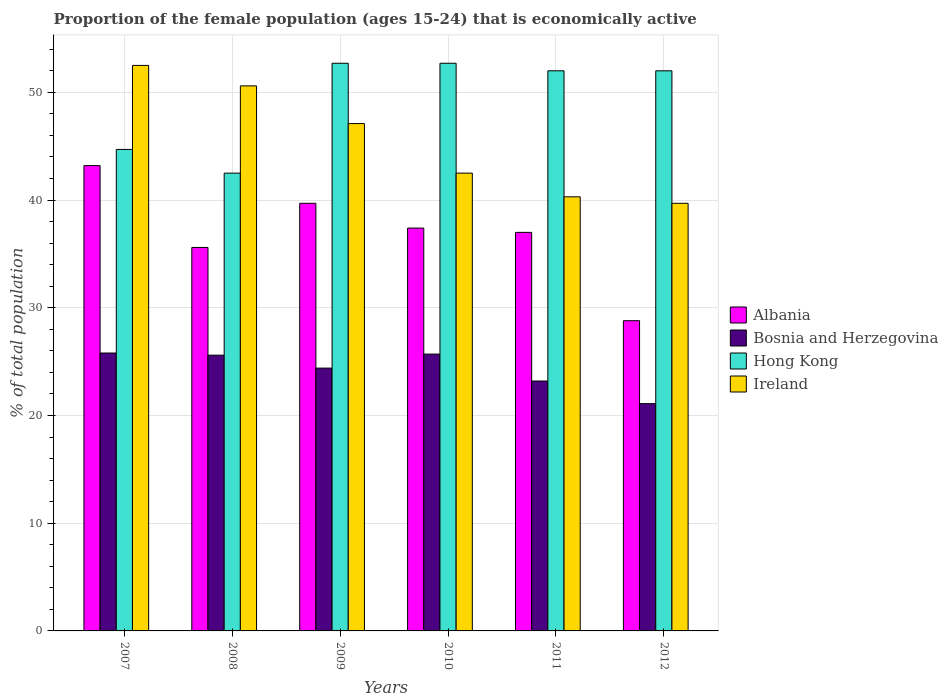How many different coloured bars are there?
Keep it short and to the point. 4. How many groups of bars are there?
Ensure brevity in your answer.  6. Are the number of bars per tick equal to the number of legend labels?
Your answer should be compact. Yes. What is the proportion of the female population that is economically active in Hong Kong in 2010?
Your answer should be very brief. 52.7. Across all years, what is the maximum proportion of the female population that is economically active in Ireland?
Keep it short and to the point. 52.5. Across all years, what is the minimum proportion of the female population that is economically active in Bosnia and Herzegovina?
Offer a terse response. 21.1. In which year was the proportion of the female population that is economically active in Hong Kong maximum?
Offer a terse response. 2009. In which year was the proportion of the female population that is economically active in Bosnia and Herzegovina minimum?
Make the answer very short. 2012. What is the total proportion of the female population that is economically active in Albania in the graph?
Your answer should be very brief. 221.7. What is the difference between the proportion of the female population that is economically active in Bosnia and Herzegovina in 2009 and that in 2010?
Make the answer very short. -1.3. What is the difference between the proportion of the female population that is economically active in Albania in 2008 and the proportion of the female population that is economically active in Bosnia and Herzegovina in 2012?
Offer a very short reply. 14.5. What is the average proportion of the female population that is economically active in Bosnia and Herzegovina per year?
Keep it short and to the point. 24.3. In the year 2012, what is the difference between the proportion of the female population that is economically active in Albania and proportion of the female population that is economically active in Hong Kong?
Your response must be concise. -23.2. In how many years, is the proportion of the female population that is economically active in Ireland greater than 52 %?
Offer a terse response. 1. What is the ratio of the proportion of the female population that is economically active in Albania in 2009 to that in 2011?
Your response must be concise. 1.07. Is the proportion of the female population that is economically active in Hong Kong in 2007 less than that in 2011?
Your answer should be very brief. Yes. What is the difference between the highest and the second highest proportion of the female population that is economically active in Bosnia and Herzegovina?
Offer a very short reply. 0.1. What is the difference between the highest and the lowest proportion of the female population that is economically active in Hong Kong?
Keep it short and to the point. 10.2. Is it the case that in every year, the sum of the proportion of the female population that is economically active in Ireland and proportion of the female population that is economically active in Bosnia and Herzegovina is greater than the sum of proportion of the female population that is economically active in Albania and proportion of the female population that is economically active in Hong Kong?
Offer a very short reply. No. What does the 4th bar from the left in 2011 represents?
Provide a short and direct response. Ireland. What does the 3rd bar from the right in 2007 represents?
Keep it short and to the point. Bosnia and Herzegovina. Are all the bars in the graph horizontal?
Your answer should be compact. No. How many years are there in the graph?
Provide a succinct answer. 6. Does the graph contain grids?
Make the answer very short. Yes. What is the title of the graph?
Provide a succinct answer. Proportion of the female population (ages 15-24) that is economically active. What is the label or title of the Y-axis?
Offer a very short reply. % of total population. What is the % of total population in Albania in 2007?
Keep it short and to the point. 43.2. What is the % of total population in Bosnia and Herzegovina in 2007?
Offer a very short reply. 25.8. What is the % of total population of Hong Kong in 2007?
Give a very brief answer. 44.7. What is the % of total population in Ireland in 2007?
Your answer should be very brief. 52.5. What is the % of total population of Albania in 2008?
Provide a short and direct response. 35.6. What is the % of total population in Bosnia and Herzegovina in 2008?
Keep it short and to the point. 25.6. What is the % of total population in Hong Kong in 2008?
Offer a very short reply. 42.5. What is the % of total population of Ireland in 2008?
Keep it short and to the point. 50.6. What is the % of total population in Albania in 2009?
Provide a short and direct response. 39.7. What is the % of total population of Bosnia and Herzegovina in 2009?
Keep it short and to the point. 24.4. What is the % of total population of Hong Kong in 2009?
Offer a very short reply. 52.7. What is the % of total population in Ireland in 2009?
Provide a short and direct response. 47.1. What is the % of total population of Albania in 2010?
Give a very brief answer. 37.4. What is the % of total population of Bosnia and Herzegovina in 2010?
Make the answer very short. 25.7. What is the % of total population of Hong Kong in 2010?
Provide a succinct answer. 52.7. What is the % of total population of Ireland in 2010?
Your response must be concise. 42.5. What is the % of total population in Albania in 2011?
Your answer should be compact. 37. What is the % of total population of Bosnia and Herzegovina in 2011?
Give a very brief answer. 23.2. What is the % of total population of Ireland in 2011?
Your answer should be compact. 40.3. What is the % of total population in Albania in 2012?
Give a very brief answer. 28.8. What is the % of total population in Bosnia and Herzegovina in 2012?
Keep it short and to the point. 21.1. What is the % of total population of Hong Kong in 2012?
Your answer should be compact. 52. What is the % of total population in Ireland in 2012?
Ensure brevity in your answer.  39.7. Across all years, what is the maximum % of total population in Albania?
Ensure brevity in your answer.  43.2. Across all years, what is the maximum % of total population of Bosnia and Herzegovina?
Your response must be concise. 25.8. Across all years, what is the maximum % of total population of Hong Kong?
Provide a succinct answer. 52.7. Across all years, what is the maximum % of total population of Ireland?
Provide a succinct answer. 52.5. Across all years, what is the minimum % of total population of Albania?
Your answer should be very brief. 28.8. Across all years, what is the minimum % of total population in Bosnia and Herzegovina?
Give a very brief answer. 21.1. Across all years, what is the minimum % of total population of Hong Kong?
Your answer should be very brief. 42.5. Across all years, what is the minimum % of total population in Ireland?
Make the answer very short. 39.7. What is the total % of total population in Albania in the graph?
Keep it short and to the point. 221.7. What is the total % of total population in Bosnia and Herzegovina in the graph?
Your answer should be compact. 145.8. What is the total % of total population in Hong Kong in the graph?
Make the answer very short. 296.6. What is the total % of total population of Ireland in the graph?
Provide a short and direct response. 272.7. What is the difference between the % of total population of Hong Kong in 2007 and that in 2008?
Keep it short and to the point. 2.2. What is the difference between the % of total population of Ireland in 2007 and that in 2008?
Your answer should be compact. 1.9. What is the difference between the % of total population in Albania in 2007 and that in 2009?
Provide a short and direct response. 3.5. What is the difference between the % of total population of Ireland in 2007 and that in 2009?
Keep it short and to the point. 5.4. What is the difference between the % of total population of Albania in 2007 and that in 2010?
Your response must be concise. 5.8. What is the difference between the % of total population of Hong Kong in 2007 and that in 2010?
Provide a short and direct response. -8. What is the difference between the % of total population in Ireland in 2007 and that in 2010?
Provide a short and direct response. 10. What is the difference between the % of total population of Bosnia and Herzegovina in 2007 and that in 2011?
Offer a very short reply. 2.6. What is the difference between the % of total population in Ireland in 2007 and that in 2011?
Provide a short and direct response. 12.2. What is the difference between the % of total population in Albania in 2008 and that in 2009?
Make the answer very short. -4.1. What is the difference between the % of total population in Hong Kong in 2008 and that in 2009?
Your answer should be compact. -10.2. What is the difference between the % of total population of Ireland in 2008 and that in 2010?
Offer a very short reply. 8.1. What is the difference between the % of total population in Ireland in 2008 and that in 2011?
Provide a short and direct response. 10.3. What is the difference between the % of total population in Bosnia and Herzegovina in 2008 and that in 2012?
Offer a very short reply. 4.5. What is the difference between the % of total population in Hong Kong in 2008 and that in 2012?
Make the answer very short. -9.5. What is the difference between the % of total population of Ireland in 2008 and that in 2012?
Your answer should be compact. 10.9. What is the difference between the % of total population of Albania in 2009 and that in 2011?
Make the answer very short. 2.7. What is the difference between the % of total population in Bosnia and Herzegovina in 2009 and that in 2011?
Keep it short and to the point. 1.2. What is the difference between the % of total population in Hong Kong in 2009 and that in 2011?
Make the answer very short. 0.7. What is the difference between the % of total population of Ireland in 2009 and that in 2011?
Keep it short and to the point. 6.8. What is the difference between the % of total population in Hong Kong in 2009 and that in 2012?
Your answer should be very brief. 0.7. What is the difference between the % of total population in Bosnia and Herzegovina in 2010 and that in 2011?
Offer a very short reply. 2.5. What is the difference between the % of total population of Hong Kong in 2010 and that in 2012?
Provide a short and direct response. 0.7. What is the difference between the % of total population of Ireland in 2010 and that in 2012?
Provide a succinct answer. 2.8. What is the difference between the % of total population in Albania in 2011 and that in 2012?
Ensure brevity in your answer.  8.2. What is the difference between the % of total population in Hong Kong in 2011 and that in 2012?
Ensure brevity in your answer.  0. What is the difference between the % of total population of Ireland in 2011 and that in 2012?
Provide a succinct answer. 0.6. What is the difference between the % of total population of Albania in 2007 and the % of total population of Ireland in 2008?
Ensure brevity in your answer.  -7.4. What is the difference between the % of total population of Bosnia and Herzegovina in 2007 and the % of total population of Hong Kong in 2008?
Make the answer very short. -16.7. What is the difference between the % of total population of Bosnia and Herzegovina in 2007 and the % of total population of Ireland in 2008?
Your response must be concise. -24.8. What is the difference between the % of total population in Hong Kong in 2007 and the % of total population in Ireland in 2008?
Your answer should be compact. -5.9. What is the difference between the % of total population in Albania in 2007 and the % of total population in Bosnia and Herzegovina in 2009?
Ensure brevity in your answer.  18.8. What is the difference between the % of total population of Albania in 2007 and the % of total population of Hong Kong in 2009?
Your response must be concise. -9.5. What is the difference between the % of total population of Bosnia and Herzegovina in 2007 and the % of total population of Hong Kong in 2009?
Your response must be concise. -26.9. What is the difference between the % of total population of Bosnia and Herzegovina in 2007 and the % of total population of Ireland in 2009?
Offer a terse response. -21.3. What is the difference between the % of total population of Hong Kong in 2007 and the % of total population of Ireland in 2009?
Provide a succinct answer. -2.4. What is the difference between the % of total population in Albania in 2007 and the % of total population in Ireland in 2010?
Your answer should be very brief. 0.7. What is the difference between the % of total population in Bosnia and Herzegovina in 2007 and the % of total population in Hong Kong in 2010?
Ensure brevity in your answer.  -26.9. What is the difference between the % of total population in Bosnia and Herzegovina in 2007 and the % of total population in Ireland in 2010?
Your answer should be very brief. -16.7. What is the difference between the % of total population in Bosnia and Herzegovina in 2007 and the % of total population in Hong Kong in 2011?
Your response must be concise. -26.2. What is the difference between the % of total population in Bosnia and Herzegovina in 2007 and the % of total population in Ireland in 2011?
Make the answer very short. -14.5. What is the difference between the % of total population in Albania in 2007 and the % of total population in Bosnia and Herzegovina in 2012?
Offer a terse response. 22.1. What is the difference between the % of total population in Albania in 2007 and the % of total population in Hong Kong in 2012?
Your answer should be compact. -8.8. What is the difference between the % of total population of Albania in 2007 and the % of total population of Ireland in 2012?
Make the answer very short. 3.5. What is the difference between the % of total population of Bosnia and Herzegovina in 2007 and the % of total population of Hong Kong in 2012?
Your response must be concise. -26.2. What is the difference between the % of total population of Albania in 2008 and the % of total population of Bosnia and Herzegovina in 2009?
Provide a succinct answer. 11.2. What is the difference between the % of total population of Albania in 2008 and the % of total population of Hong Kong in 2009?
Your answer should be very brief. -17.1. What is the difference between the % of total population of Albania in 2008 and the % of total population of Ireland in 2009?
Offer a very short reply. -11.5. What is the difference between the % of total population in Bosnia and Herzegovina in 2008 and the % of total population in Hong Kong in 2009?
Provide a succinct answer. -27.1. What is the difference between the % of total population in Bosnia and Herzegovina in 2008 and the % of total population in Ireland in 2009?
Your response must be concise. -21.5. What is the difference between the % of total population in Hong Kong in 2008 and the % of total population in Ireland in 2009?
Offer a terse response. -4.6. What is the difference between the % of total population of Albania in 2008 and the % of total population of Bosnia and Herzegovina in 2010?
Provide a short and direct response. 9.9. What is the difference between the % of total population of Albania in 2008 and the % of total population of Hong Kong in 2010?
Offer a terse response. -17.1. What is the difference between the % of total population of Bosnia and Herzegovina in 2008 and the % of total population of Hong Kong in 2010?
Make the answer very short. -27.1. What is the difference between the % of total population of Bosnia and Herzegovina in 2008 and the % of total population of Ireland in 2010?
Your response must be concise. -16.9. What is the difference between the % of total population in Hong Kong in 2008 and the % of total population in Ireland in 2010?
Make the answer very short. 0. What is the difference between the % of total population in Albania in 2008 and the % of total population in Hong Kong in 2011?
Provide a succinct answer. -16.4. What is the difference between the % of total population in Bosnia and Herzegovina in 2008 and the % of total population in Hong Kong in 2011?
Give a very brief answer. -26.4. What is the difference between the % of total population in Bosnia and Herzegovina in 2008 and the % of total population in Ireland in 2011?
Keep it short and to the point. -14.7. What is the difference between the % of total population in Hong Kong in 2008 and the % of total population in Ireland in 2011?
Provide a short and direct response. 2.2. What is the difference between the % of total population in Albania in 2008 and the % of total population in Bosnia and Herzegovina in 2012?
Your answer should be compact. 14.5. What is the difference between the % of total population of Albania in 2008 and the % of total population of Hong Kong in 2012?
Keep it short and to the point. -16.4. What is the difference between the % of total population in Albania in 2008 and the % of total population in Ireland in 2012?
Ensure brevity in your answer.  -4.1. What is the difference between the % of total population of Bosnia and Herzegovina in 2008 and the % of total population of Hong Kong in 2012?
Keep it short and to the point. -26.4. What is the difference between the % of total population of Bosnia and Herzegovina in 2008 and the % of total population of Ireland in 2012?
Give a very brief answer. -14.1. What is the difference between the % of total population of Albania in 2009 and the % of total population of Bosnia and Herzegovina in 2010?
Offer a very short reply. 14. What is the difference between the % of total population of Bosnia and Herzegovina in 2009 and the % of total population of Hong Kong in 2010?
Keep it short and to the point. -28.3. What is the difference between the % of total population in Bosnia and Herzegovina in 2009 and the % of total population in Ireland in 2010?
Offer a very short reply. -18.1. What is the difference between the % of total population of Hong Kong in 2009 and the % of total population of Ireland in 2010?
Provide a succinct answer. 10.2. What is the difference between the % of total population in Albania in 2009 and the % of total population in Bosnia and Herzegovina in 2011?
Offer a very short reply. 16.5. What is the difference between the % of total population in Albania in 2009 and the % of total population in Hong Kong in 2011?
Offer a very short reply. -12.3. What is the difference between the % of total population in Bosnia and Herzegovina in 2009 and the % of total population in Hong Kong in 2011?
Offer a very short reply. -27.6. What is the difference between the % of total population of Bosnia and Herzegovina in 2009 and the % of total population of Ireland in 2011?
Give a very brief answer. -15.9. What is the difference between the % of total population of Hong Kong in 2009 and the % of total population of Ireland in 2011?
Provide a short and direct response. 12.4. What is the difference between the % of total population in Albania in 2009 and the % of total population in Bosnia and Herzegovina in 2012?
Ensure brevity in your answer.  18.6. What is the difference between the % of total population in Albania in 2009 and the % of total population in Hong Kong in 2012?
Ensure brevity in your answer.  -12.3. What is the difference between the % of total population in Albania in 2009 and the % of total population in Ireland in 2012?
Your answer should be very brief. 0. What is the difference between the % of total population of Bosnia and Herzegovina in 2009 and the % of total population of Hong Kong in 2012?
Provide a short and direct response. -27.6. What is the difference between the % of total population in Bosnia and Herzegovina in 2009 and the % of total population in Ireland in 2012?
Ensure brevity in your answer.  -15.3. What is the difference between the % of total population in Albania in 2010 and the % of total population in Hong Kong in 2011?
Ensure brevity in your answer.  -14.6. What is the difference between the % of total population in Bosnia and Herzegovina in 2010 and the % of total population in Hong Kong in 2011?
Offer a very short reply. -26.3. What is the difference between the % of total population of Bosnia and Herzegovina in 2010 and the % of total population of Ireland in 2011?
Give a very brief answer. -14.6. What is the difference between the % of total population in Albania in 2010 and the % of total population in Bosnia and Herzegovina in 2012?
Offer a very short reply. 16.3. What is the difference between the % of total population in Albania in 2010 and the % of total population in Hong Kong in 2012?
Provide a short and direct response. -14.6. What is the difference between the % of total population of Albania in 2010 and the % of total population of Ireland in 2012?
Provide a short and direct response. -2.3. What is the difference between the % of total population of Bosnia and Herzegovina in 2010 and the % of total population of Hong Kong in 2012?
Offer a terse response. -26.3. What is the difference between the % of total population in Albania in 2011 and the % of total population in Hong Kong in 2012?
Your response must be concise. -15. What is the difference between the % of total population in Bosnia and Herzegovina in 2011 and the % of total population in Hong Kong in 2012?
Make the answer very short. -28.8. What is the difference between the % of total population of Bosnia and Herzegovina in 2011 and the % of total population of Ireland in 2012?
Provide a short and direct response. -16.5. What is the difference between the % of total population in Hong Kong in 2011 and the % of total population in Ireland in 2012?
Ensure brevity in your answer.  12.3. What is the average % of total population of Albania per year?
Provide a short and direct response. 36.95. What is the average % of total population of Bosnia and Herzegovina per year?
Your answer should be compact. 24.3. What is the average % of total population of Hong Kong per year?
Keep it short and to the point. 49.43. What is the average % of total population of Ireland per year?
Make the answer very short. 45.45. In the year 2007, what is the difference between the % of total population in Albania and % of total population in Hong Kong?
Keep it short and to the point. -1.5. In the year 2007, what is the difference between the % of total population in Albania and % of total population in Ireland?
Your response must be concise. -9.3. In the year 2007, what is the difference between the % of total population in Bosnia and Herzegovina and % of total population in Hong Kong?
Your response must be concise. -18.9. In the year 2007, what is the difference between the % of total population in Bosnia and Herzegovina and % of total population in Ireland?
Offer a very short reply. -26.7. In the year 2007, what is the difference between the % of total population in Hong Kong and % of total population in Ireland?
Make the answer very short. -7.8. In the year 2008, what is the difference between the % of total population in Albania and % of total population in Bosnia and Herzegovina?
Ensure brevity in your answer.  10. In the year 2008, what is the difference between the % of total population in Albania and % of total population in Hong Kong?
Your answer should be compact. -6.9. In the year 2008, what is the difference between the % of total population of Albania and % of total population of Ireland?
Your answer should be very brief. -15. In the year 2008, what is the difference between the % of total population in Bosnia and Herzegovina and % of total population in Hong Kong?
Give a very brief answer. -16.9. In the year 2008, what is the difference between the % of total population in Bosnia and Herzegovina and % of total population in Ireland?
Your answer should be very brief. -25. In the year 2009, what is the difference between the % of total population in Albania and % of total population in Bosnia and Herzegovina?
Offer a terse response. 15.3. In the year 2009, what is the difference between the % of total population in Bosnia and Herzegovina and % of total population in Hong Kong?
Your answer should be very brief. -28.3. In the year 2009, what is the difference between the % of total population of Bosnia and Herzegovina and % of total population of Ireland?
Your answer should be compact. -22.7. In the year 2010, what is the difference between the % of total population of Albania and % of total population of Bosnia and Herzegovina?
Give a very brief answer. 11.7. In the year 2010, what is the difference between the % of total population in Albania and % of total population in Hong Kong?
Provide a short and direct response. -15.3. In the year 2010, what is the difference between the % of total population in Albania and % of total population in Ireland?
Provide a short and direct response. -5.1. In the year 2010, what is the difference between the % of total population in Bosnia and Herzegovina and % of total population in Hong Kong?
Your answer should be very brief. -27. In the year 2010, what is the difference between the % of total population in Bosnia and Herzegovina and % of total population in Ireland?
Give a very brief answer. -16.8. In the year 2011, what is the difference between the % of total population of Albania and % of total population of Bosnia and Herzegovina?
Offer a very short reply. 13.8. In the year 2011, what is the difference between the % of total population in Bosnia and Herzegovina and % of total population in Hong Kong?
Provide a succinct answer. -28.8. In the year 2011, what is the difference between the % of total population of Bosnia and Herzegovina and % of total population of Ireland?
Provide a succinct answer. -17.1. In the year 2011, what is the difference between the % of total population in Hong Kong and % of total population in Ireland?
Offer a terse response. 11.7. In the year 2012, what is the difference between the % of total population of Albania and % of total population of Bosnia and Herzegovina?
Your answer should be compact. 7.7. In the year 2012, what is the difference between the % of total population in Albania and % of total population in Hong Kong?
Your answer should be very brief. -23.2. In the year 2012, what is the difference between the % of total population of Albania and % of total population of Ireland?
Give a very brief answer. -10.9. In the year 2012, what is the difference between the % of total population of Bosnia and Herzegovina and % of total population of Hong Kong?
Keep it short and to the point. -30.9. In the year 2012, what is the difference between the % of total population of Bosnia and Herzegovina and % of total population of Ireland?
Give a very brief answer. -18.6. What is the ratio of the % of total population in Albania in 2007 to that in 2008?
Your response must be concise. 1.21. What is the ratio of the % of total population in Hong Kong in 2007 to that in 2008?
Make the answer very short. 1.05. What is the ratio of the % of total population of Ireland in 2007 to that in 2008?
Offer a terse response. 1.04. What is the ratio of the % of total population in Albania in 2007 to that in 2009?
Provide a short and direct response. 1.09. What is the ratio of the % of total population of Bosnia and Herzegovina in 2007 to that in 2009?
Provide a short and direct response. 1.06. What is the ratio of the % of total population in Hong Kong in 2007 to that in 2009?
Make the answer very short. 0.85. What is the ratio of the % of total population of Ireland in 2007 to that in 2009?
Your answer should be very brief. 1.11. What is the ratio of the % of total population in Albania in 2007 to that in 2010?
Make the answer very short. 1.16. What is the ratio of the % of total population of Bosnia and Herzegovina in 2007 to that in 2010?
Ensure brevity in your answer.  1. What is the ratio of the % of total population in Hong Kong in 2007 to that in 2010?
Provide a short and direct response. 0.85. What is the ratio of the % of total population of Ireland in 2007 to that in 2010?
Make the answer very short. 1.24. What is the ratio of the % of total population of Albania in 2007 to that in 2011?
Your answer should be compact. 1.17. What is the ratio of the % of total population in Bosnia and Herzegovina in 2007 to that in 2011?
Your answer should be compact. 1.11. What is the ratio of the % of total population of Hong Kong in 2007 to that in 2011?
Your answer should be compact. 0.86. What is the ratio of the % of total population in Ireland in 2007 to that in 2011?
Provide a succinct answer. 1.3. What is the ratio of the % of total population of Albania in 2007 to that in 2012?
Your response must be concise. 1.5. What is the ratio of the % of total population in Bosnia and Herzegovina in 2007 to that in 2012?
Your answer should be compact. 1.22. What is the ratio of the % of total population in Hong Kong in 2007 to that in 2012?
Your response must be concise. 0.86. What is the ratio of the % of total population of Ireland in 2007 to that in 2012?
Offer a terse response. 1.32. What is the ratio of the % of total population in Albania in 2008 to that in 2009?
Provide a succinct answer. 0.9. What is the ratio of the % of total population in Bosnia and Herzegovina in 2008 to that in 2009?
Keep it short and to the point. 1.05. What is the ratio of the % of total population in Hong Kong in 2008 to that in 2009?
Keep it short and to the point. 0.81. What is the ratio of the % of total population of Ireland in 2008 to that in 2009?
Keep it short and to the point. 1.07. What is the ratio of the % of total population in Albania in 2008 to that in 2010?
Your answer should be compact. 0.95. What is the ratio of the % of total population in Bosnia and Herzegovina in 2008 to that in 2010?
Provide a succinct answer. 1. What is the ratio of the % of total population in Hong Kong in 2008 to that in 2010?
Offer a very short reply. 0.81. What is the ratio of the % of total population in Ireland in 2008 to that in 2010?
Your answer should be very brief. 1.19. What is the ratio of the % of total population of Albania in 2008 to that in 2011?
Your response must be concise. 0.96. What is the ratio of the % of total population of Bosnia and Herzegovina in 2008 to that in 2011?
Ensure brevity in your answer.  1.1. What is the ratio of the % of total population in Hong Kong in 2008 to that in 2011?
Give a very brief answer. 0.82. What is the ratio of the % of total population of Ireland in 2008 to that in 2011?
Provide a succinct answer. 1.26. What is the ratio of the % of total population of Albania in 2008 to that in 2012?
Offer a terse response. 1.24. What is the ratio of the % of total population in Bosnia and Herzegovina in 2008 to that in 2012?
Provide a short and direct response. 1.21. What is the ratio of the % of total population of Hong Kong in 2008 to that in 2012?
Make the answer very short. 0.82. What is the ratio of the % of total population of Ireland in 2008 to that in 2012?
Your response must be concise. 1.27. What is the ratio of the % of total population of Albania in 2009 to that in 2010?
Your answer should be very brief. 1.06. What is the ratio of the % of total population in Bosnia and Herzegovina in 2009 to that in 2010?
Offer a very short reply. 0.95. What is the ratio of the % of total population of Hong Kong in 2009 to that in 2010?
Provide a short and direct response. 1. What is the ratio of the % of total population in Ireland in 2009 to that in 2010?
Your answer should be very brief. 1.11. What is the ratio of the % of total population of Albania in 2009 to that in 2011?
Keep it short and to the point. 1.07. What is the ratio of the % of total population in Bosnia and Herzegovina in 2009 to that in 2011?
Your answer should be very brief. 1.05. What is the ratio of the % of total population in Hong Kong in 2009 to that in 2011?
Give a very brief answer. 1.01. What is the ratio of the % of total population of Ireland in 2009 to that in 2011?
Give a very brief answer. 1.17. What is the ratio of the % of total population in Albania in 2009 to that in 2012?
Your response must be concise. 1.38. What is the ratio of the % of total population of Bosnia and Herzegovina in 2009 to that in 2012?
Make the answer very short. 1.16. What is the ratio of the % of total population in Hong Kong in 2009 to that in 2012?
Keep it short and to the point. 1.01. What is the ratio of the % of total population in Ireland in 2009 to that in 2012?
Ensure brevity in your answer.  1.19. What is the ratio of the % of total population in Albania in 2010 to that in 2011?
Keep it short and to the point. 1.01. What is the ratio of the % of total population of Bosnia and Herzegovina in 2010 to that in 2011?
Give a very brief answer. 1.11. What is the ratio of the % of total population in Hong Kong in 2010 to that in 2011?
Offer a terse response. 1.01. What is the ratio of the % of total population of Ireland in 2010 to that in 2011?
Your answer should be very brief. 1.05. What is the ratio of the % of total population of Albania in 2010 to that in 2012?
Your answer should be compact. 1.3. What is the ratio of the % of total population in Bosnia and Herzegovina in 2010 to that in 2012?
Provide a succinct answer. 1.22. What is the ratio of the % of total population of Hong Kong in 2010 to that in 2012?
Offer a terse response. 1.01. What is the ratio of the % of total population in Ireland in 2010 to that in 2012?
Your answer should be compact. 1.07. What is the ratio of the % of total population of Albania in 2011 to that in 2012?
Give a very brief answer. 1.28. What is the ratio of the % of total population of Bosnia and Herzegovina in 2011 to that in 2012?
Ensure brevity in your answer.  1.1. What is the ratio of the % of total population in Ireland in 2011 to that in 2012?
Provide a succinct answer. 1.02. What is the difference between the highest and the second highest % of total population in Albania?
Your answer should be very brief. 3.5. What is the difference between the highest and the second highest % of total population of Bosnia and Herzegovina?
Offer a terse response. 0.1. What is the difference between the highest and the second highest % of total population in Ireland?
Make the answer very short. 1.9. What is the difference between the highest and the lowest % of total population of Ireland?
Provide a succinct answer. 12.8. 